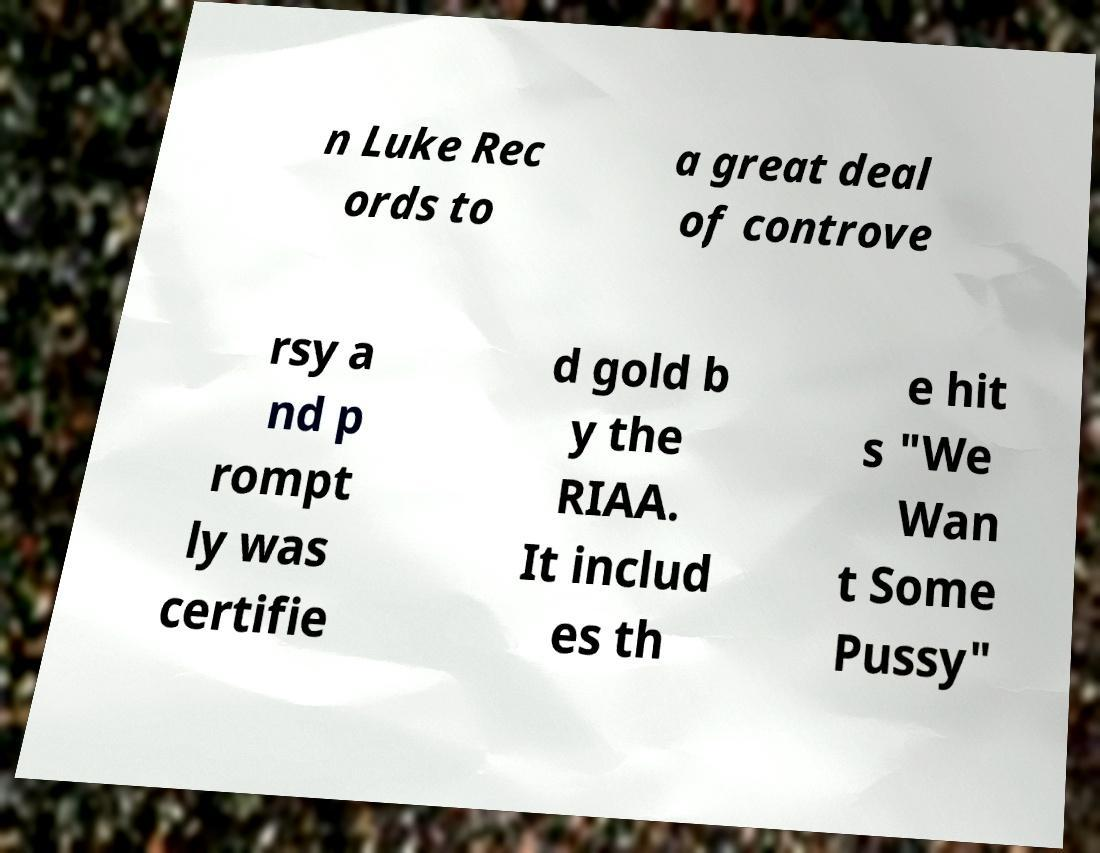Can you read and provide the text displayed in the image?This photo seems to have some interesting text. Can you extract and type it out for me? n Luke Rec ords to a great deal of controve rsy a nd p rompt ly was certifie d gold b y the RIAA. It includ es th e hit s "We Wan t Some Pussy" 